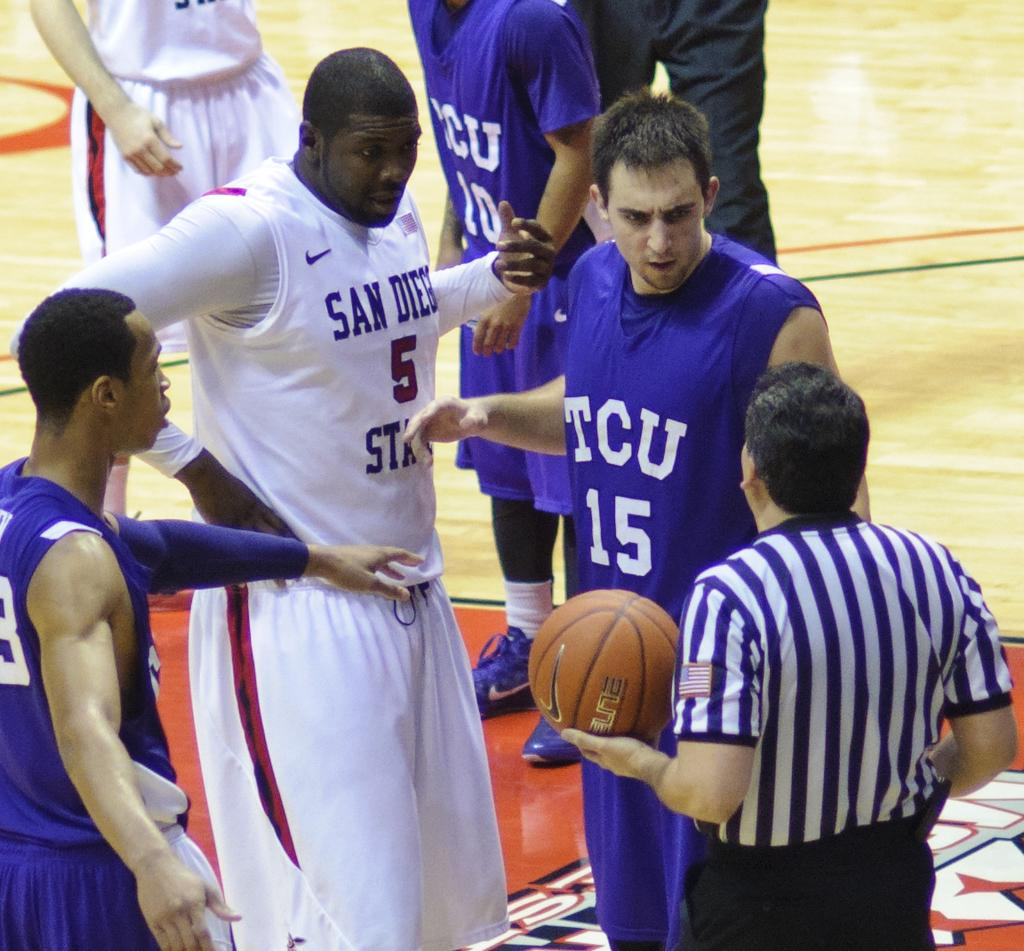What are the people in the image doing? The people in the image are standing on the floor. Can you describe what the man is holding in his hand? The man is holding a basketball in his hand. What type of church can be seen in the background of the image? There is no church present in the image; it only shows people standing on the floor and a man holding a basketball. 